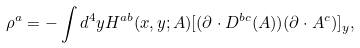<formula> <loc_0><loc_0><loc_500><loc_500>\rho ^ { a } = - \int d ^ { 4 } y H ^ { a b } ( x , y ; A ) [ ( \partial \cdot D ^ { b c } ( A ) ) ( \partial \cdot A ^ { c } ) ] _ { y } ,</formula> 